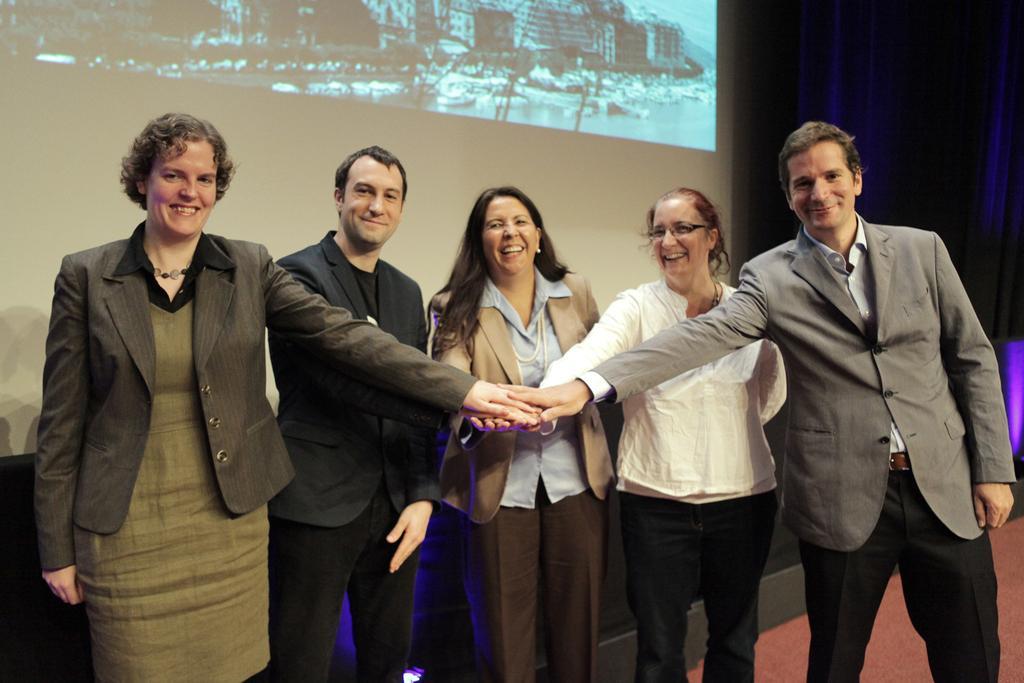How would you summarize this image in a sentence or two? In this image I can see the group of people with different color dresses. I can see the screen and the black background. 